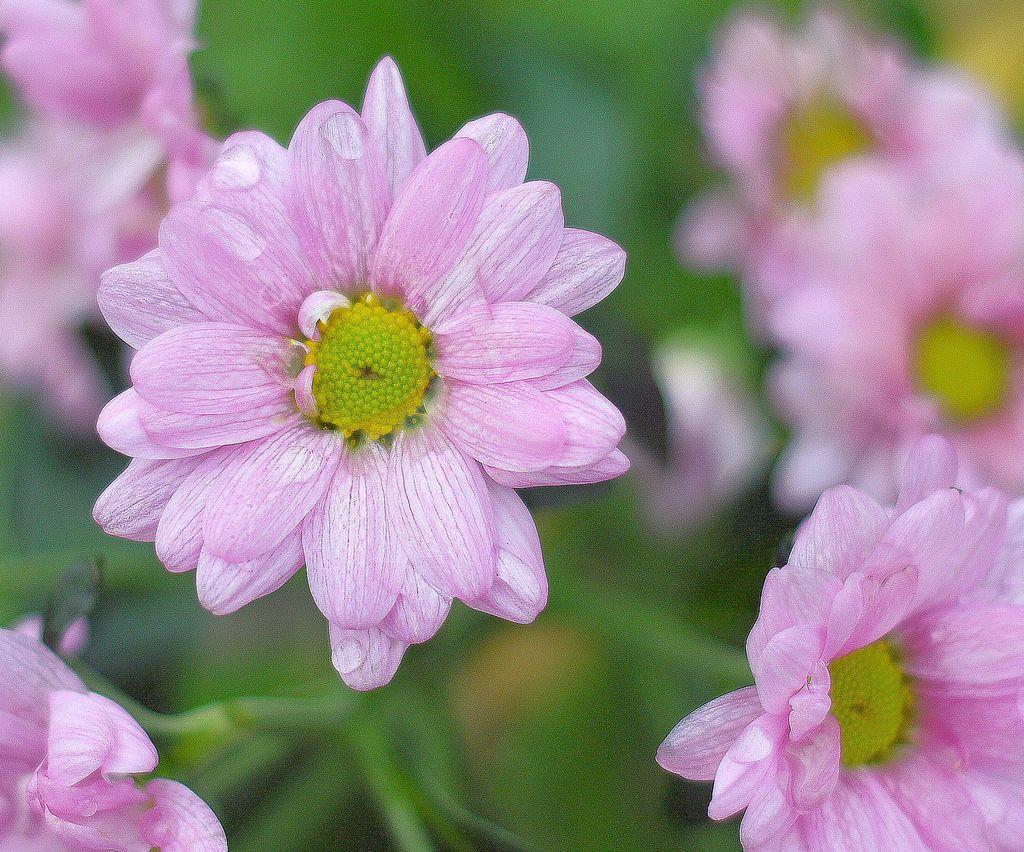Please provide a concise description of this image. In this image we can see pink flowers. Background it is blur. 